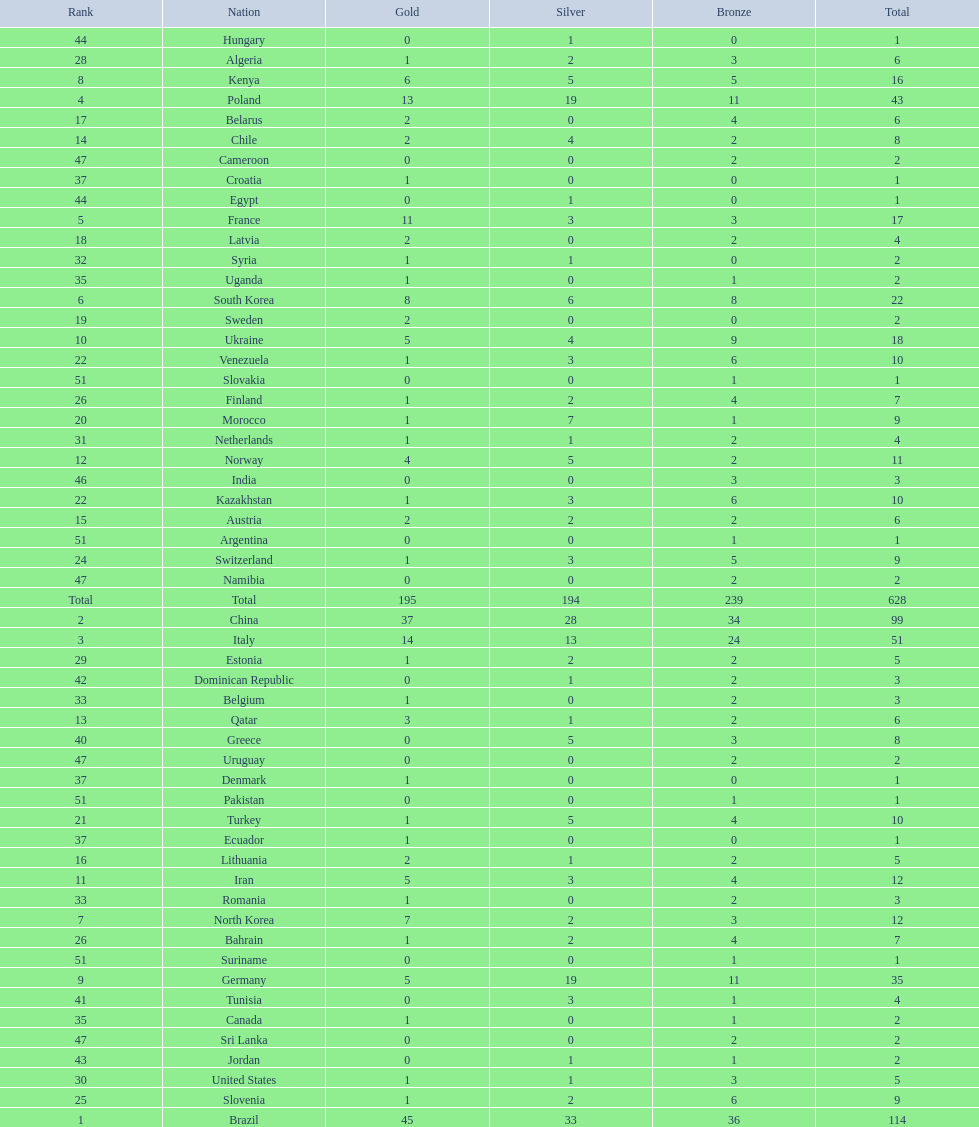What is the difference in medal count between south korea and north korea? 10. 